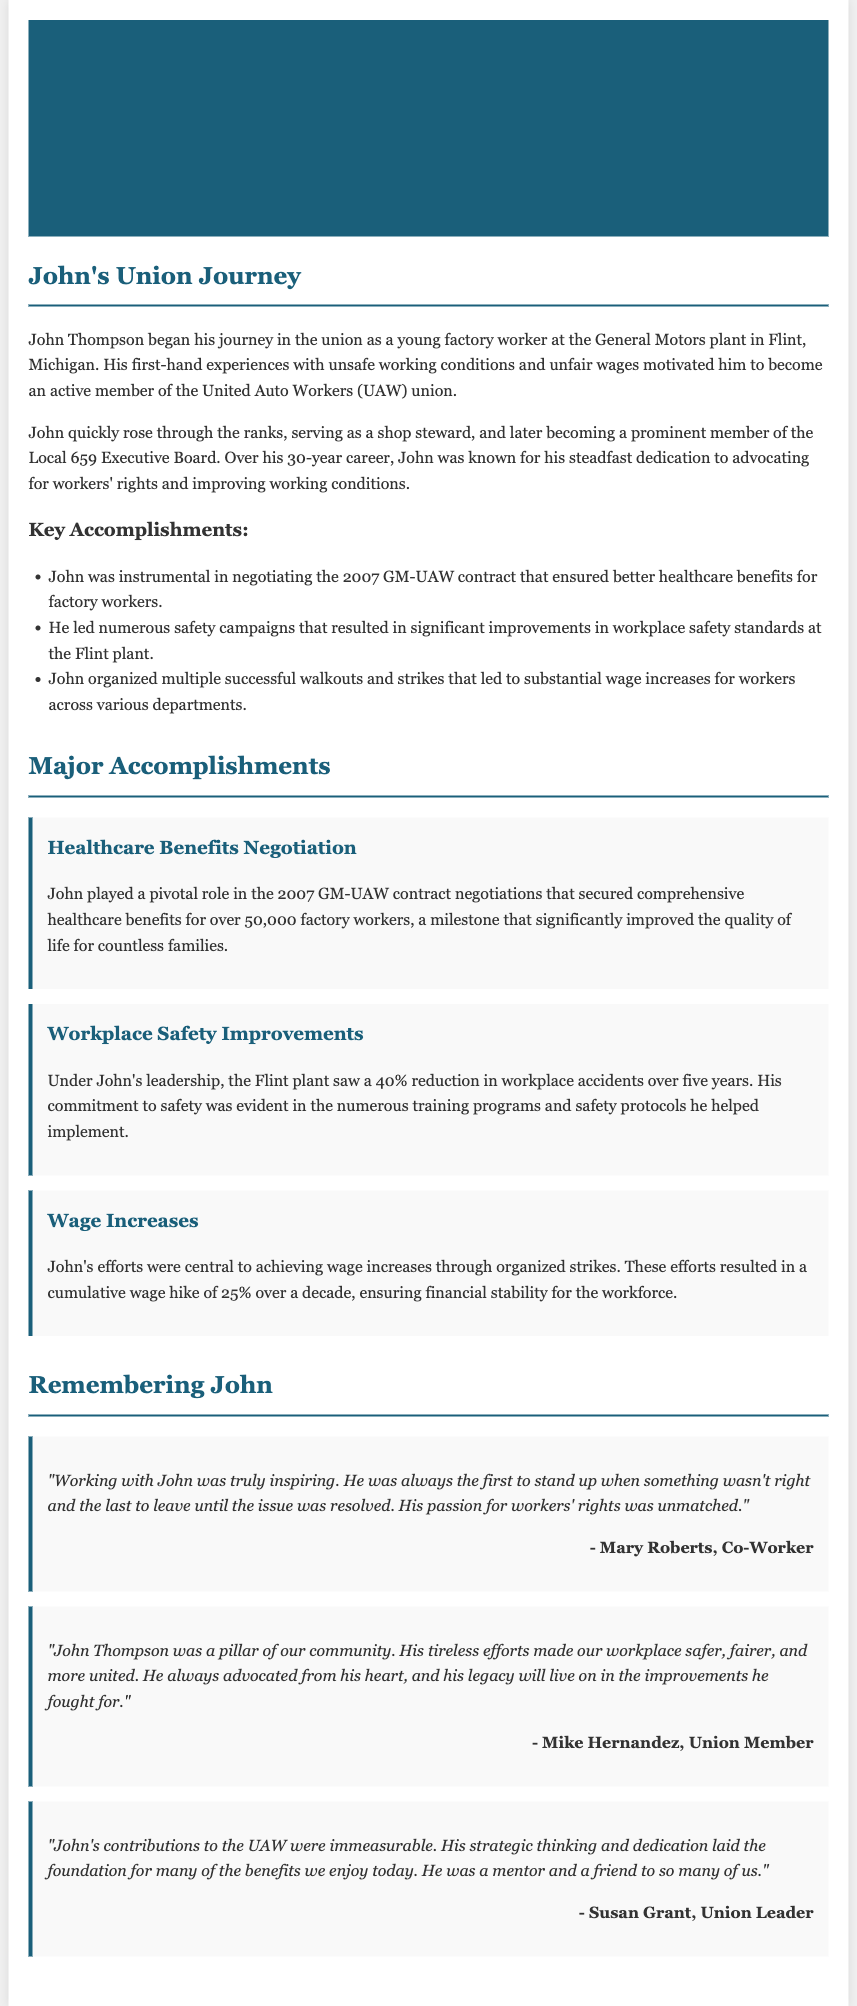What was John Thompson's first union role? John began his journey in the union as a young factory worker.
Answer: Young factory worker In what city did John work when he started his union journey? John began his journey in the union at the General Motors plant in Flint, Michigan.
Answer: Flint, Michigan How many years did John serve in the union? John served over a 30-year career in the union.
Answer: 30 years What percentage reduction in workplace accidents did the Flint plant see under John's leadership? The Flint plant saw a 40% reduction in workplace accidents.
Answer: 40% Who was quoted stating that John was always the first to stand up when something wasn't right? Mary Roberts was quoted about John's dedication to advocacy.
Answer: Mary Roberts What significant financial improvement did John’s efforts lead to over a decade? John’s efforts resulted in a cumulative wage hike of 25%.
Answer: 25% Which union contract negotiation did John play a pivotal role in? John played a pivotal role in the 2007 GM-UAW contract negotiations.
Answer: 2007 GM-UAW contract What is one of the key responsibilities John held within the union? John served as a shop steward and later on the Local 659 Executive Board.
Answer: Shop steward Which campaign did John lead that resulted in improvements in workplace safety standards? John led numerous safety campaigns at the Flint plant.
Answer: Safety campaigns 